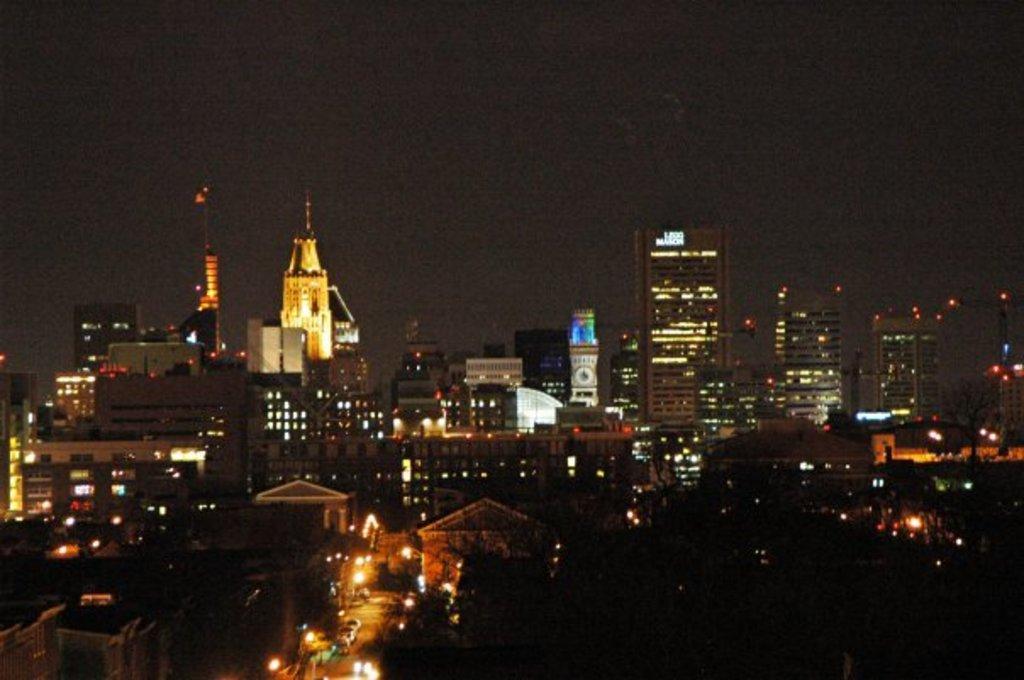Please provide a concise description of this image. This image consists of houses, buildings, lights, towers, fleets of vehicles on the road, trees and the sky. This image is taken may be during night. 